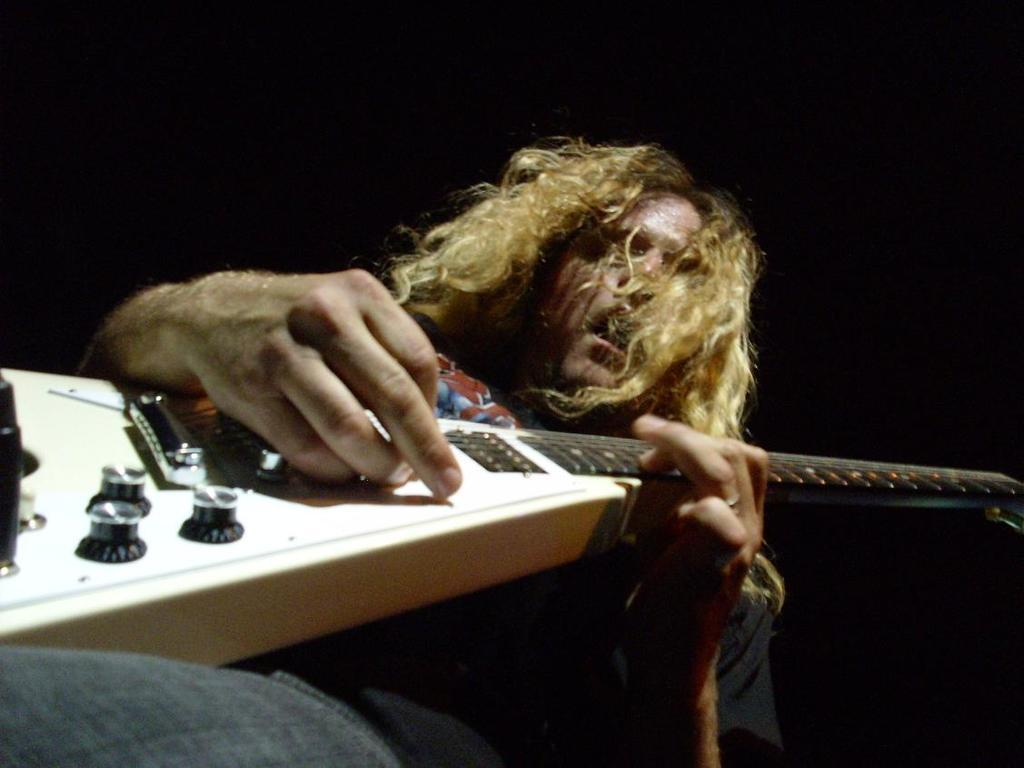What is the main subject of the image? The main subject of the image is a man. What is the man holding in the image? The man is holding a guitar. How many units can be seen smashing the guitar in the image? There are no units present in the image, nor is the guitar being smashed. 